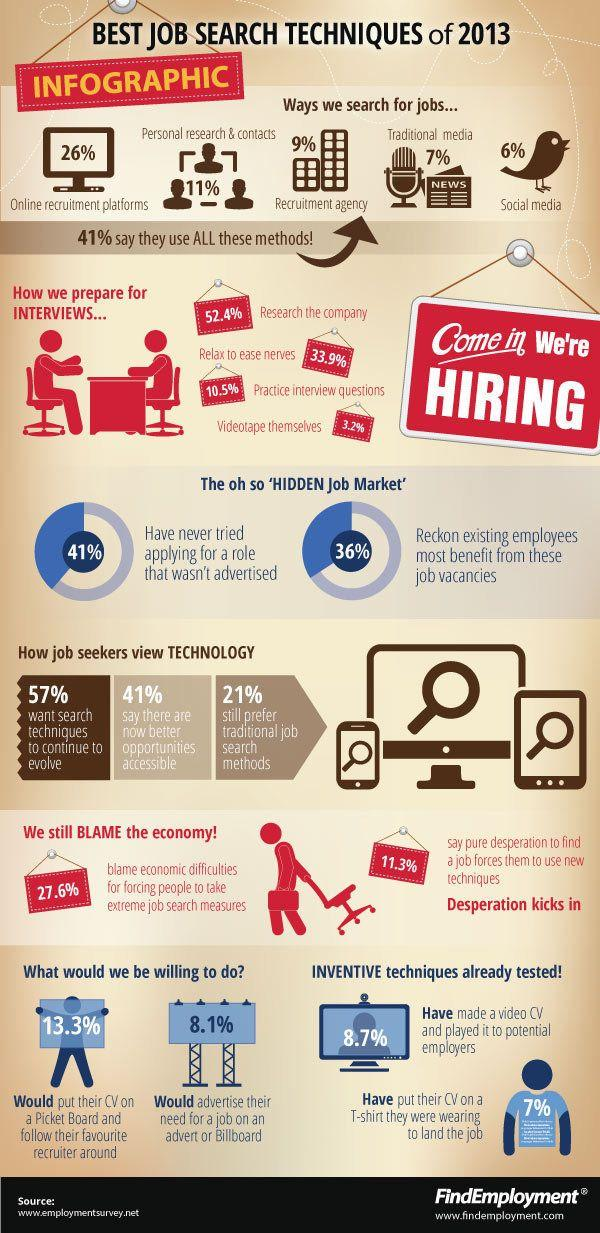List a handful of essential elements in this visual. According to the survey, 59% of people have tried applying for a role that wasn't advertised. According to a recent survey, 8.1% of individuals advertised a need for a job on a billboard. Many individuals conduct research on the company they are interviewing with beforehand during the preparation process for job interviews. The information was obtained from the website <www.employmentsurvey.net>. The best method for job search is using online recruitment platforms. 